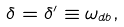Convert formula to latex. <formula><loc_0><loc_0><loc_500><loc_500>\delta = \delta ^ { \prime } \equiv \omega _ { d b } ,</formula> 